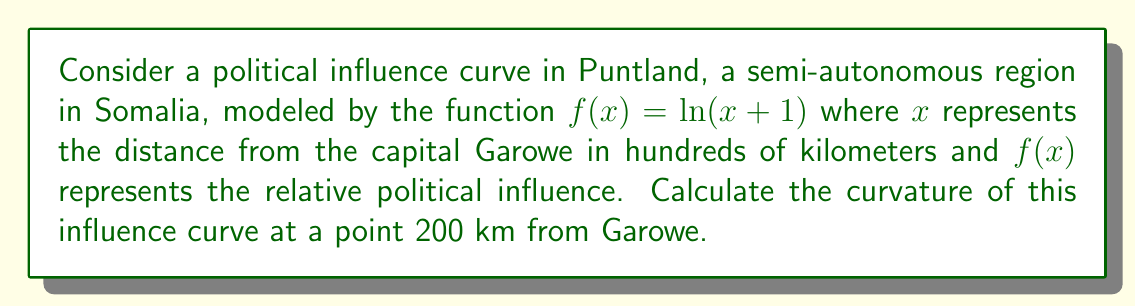Give your solution to this math problem. To calculate the curvature of the political influence curve, we'll follow these steps:

1) The formula for curvature $K$ of a function $y = f(x)$ is:

   $$K = \frac{|f''(x)|}{(1 + [f'(x)]^2)^{3/2}}$$

2) First, let's find $f'(x)$ and $f''(x)$:
   
   $f(x) = \ln(x+1)$
   $f'(x) = \frac{1}{x+1}$
   $f''(x) = -\frac{1}{(x+1)^2}$

3) At 200 km from Garowe, $x = 2$ (since $x$ is in hundreds of kilometers).

4) Now, let's calculate $f'(2)$ and $f''(2)$:
   
   $f'(2) = \frac{1}{2+1} = \frac{1}{3}$
   $f''(2) = -\frac{1}{(2+1)^2} = -\frac{1}{9}$

5) Substituting these values into the curvature formula:

   $$K = \frac{|-\frac{1}{9}|}{(1 + [\frac{1}{3}]^2)^{3/2}}$$

6) Simplify:
   
   $$K = \frac{\frac{1}{9}}{(1 + \frac{1}{9})^{3/2}} = \frac{\frac{1}{9}}{(\frac{10}{9})^{3/2}} = \frac{1}{9} \cdot (\frac{9}{10})^{3/2}$$

7) Calculate the final result:
   
   $$K \approx 0.0823$$

This value represents the curvature of the political influence curve 200 km from Garowe.
Answer: $K \approx 0.0823$ 